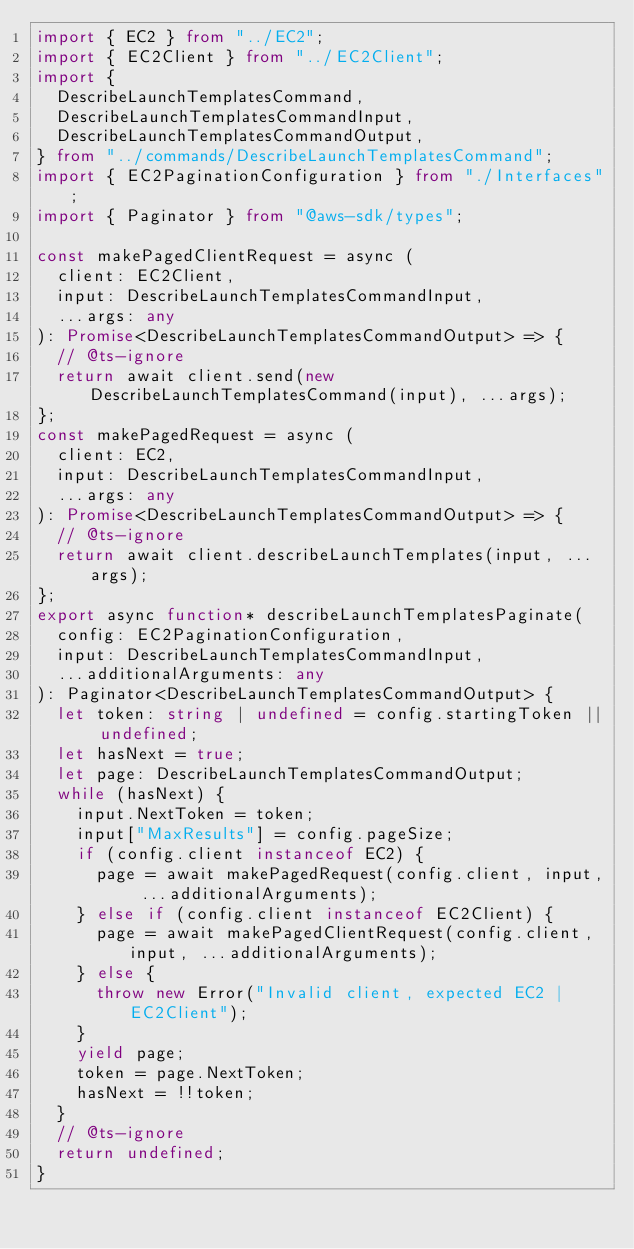<code> <loc_0><loc_0><loc_500><loc_500><_TypeScript_>import { EC2 } from "../EC2";
import { EC2Client } from "../EC2Client";
import {
  DescribeLaunchTemplatesCommand,
  DescribeLaunchTemplatesCommandInput,
  DescribeLaunchTemplatesCommandOutput,
} from "../commands/DescribeLaunchTemplatesCommand";
import { EC2PaginationConfiguration } from "./Interfaces";
import { Paginator } from "@aws-sdk/types";

const makePagedClientRequest = async (
  client: EC2Client,
  input: DescribeLaunchTemplatesCommandInput,
  ...args: any
): Promise<DescribeLaunchTemplatesCommandOutput> => {
  // @ts-ignore
  return await client.send(new DescribeLaunchTemplatesCommand(input), ...args);
};
const makePagedRequest = async (
  client: EC2,
  input: DescribeLaunchTemplatesCommandInput,
  ...args: any
): Promise<DescribeLaunchTemplatesCommandOutput> => {
  // @ts-ignore
  return await client.describeLaunchTemplates(input, ...args);
};
export async function* describeLaunchTemplatesPaginate(
  config: EC2PaginationConfiguration,
  input: DescribeLaunchTemplatesCommandInput,
  ...additionalArguments: any
): Paginator<DescribeLaunchTemplatesCommandOutput> {
  let token: string | undefined = config.startingToken || undefined;
  let hasNext = true;
  let page: DescribeLaunchTemplatesCommandOutput;
  while (hasNext) {
    input.NextToken = token;
    input["MaxResults"] = config.pageSize;
    if (config.client instanceof EC2) {
      page = await makePagedRequest(config.client, input, ...additionalArguments);
    } else if (config.client instanceof EC2Client) {
      page = await makePagedClientRequest(config.client, input, ...additionalArguments);
    } else {
      throw new Error("Invalid client, expected EC2 | EC2Client");
    }
    yield page;
    token = page.NextToken;
    hasNext = !!token;
  }
  // @ts-ignore
  return undefined;
}
</code> 